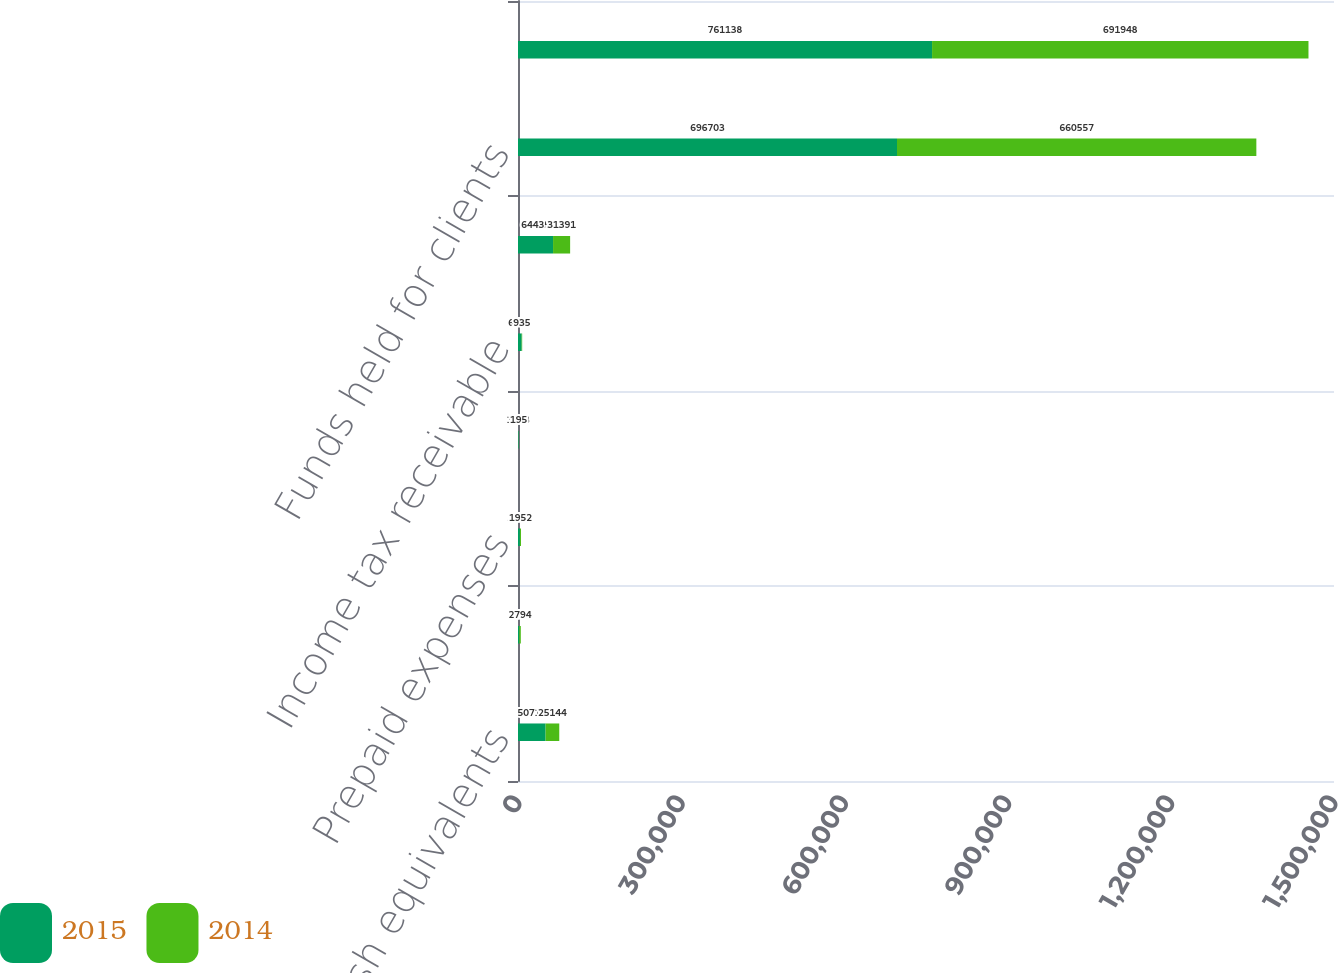Convert chart. <chart><loc_0><loc_0><loc_500><loc_500><stacked_bar_chart><ecel><fcel>Cash and cash equivalents<fcel>Accounts receivable<fcel>Prepaid expenses<fcel>Inventory<fcel>Income tax receivable<fcel>Current assets before funds<fcel>Funds held for clients<fcel>Total current assets<nl><fcel>2015<fcel>50714<fcel>2354<fcel>3531<fcel>1093<fcel>6743<fcel>64435<fcel>696703<fcel>761138<nl><fcel>2014<fcel>25144<fcel>2794<fcel>1952<fcel>195<fcel>935<fcel>31391<fcel>660557<fcel>691948<nl></chart> 